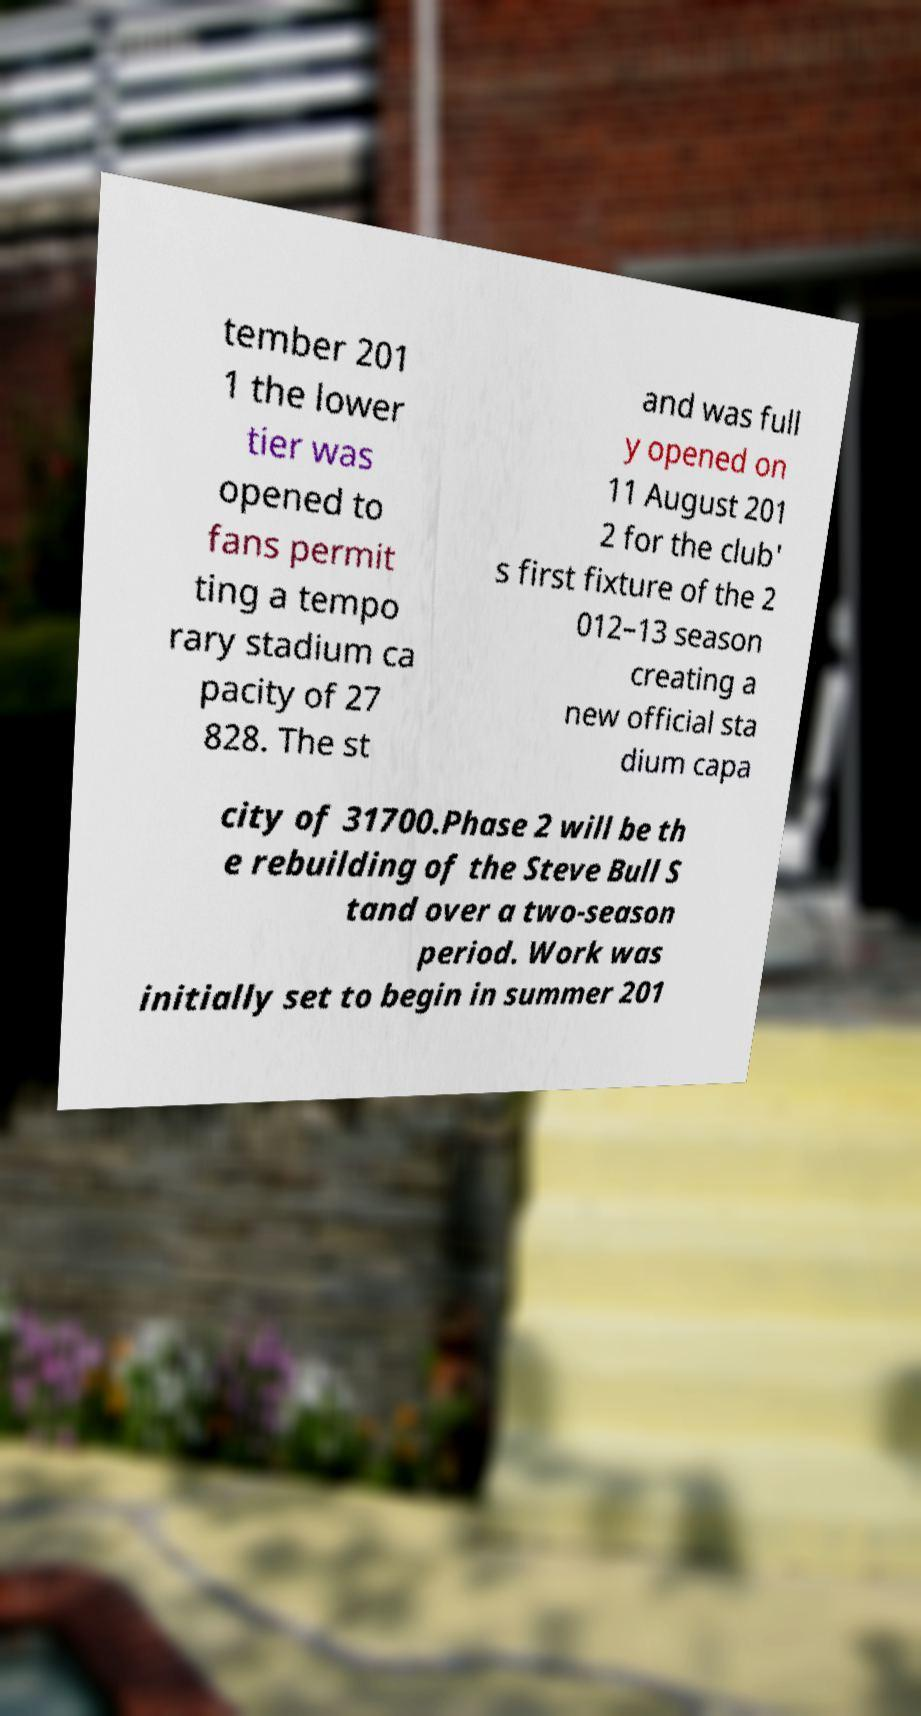What messages or text are displayed in this image? I need them in a readable, typed format. tember 201 1 the lower tier was opened to fans permit ting a tempo rary stadium ca pacity of 27 828. The st and was full y opened on 11 August 201 2 for the club' s first fixture of the 2 012–13 season creating a new official sta dium capa city of 31700.Phase 2 will be th e rebuilding of the Steve Bull S tand over a two-season period. Work was initially set to begin in summer 201 